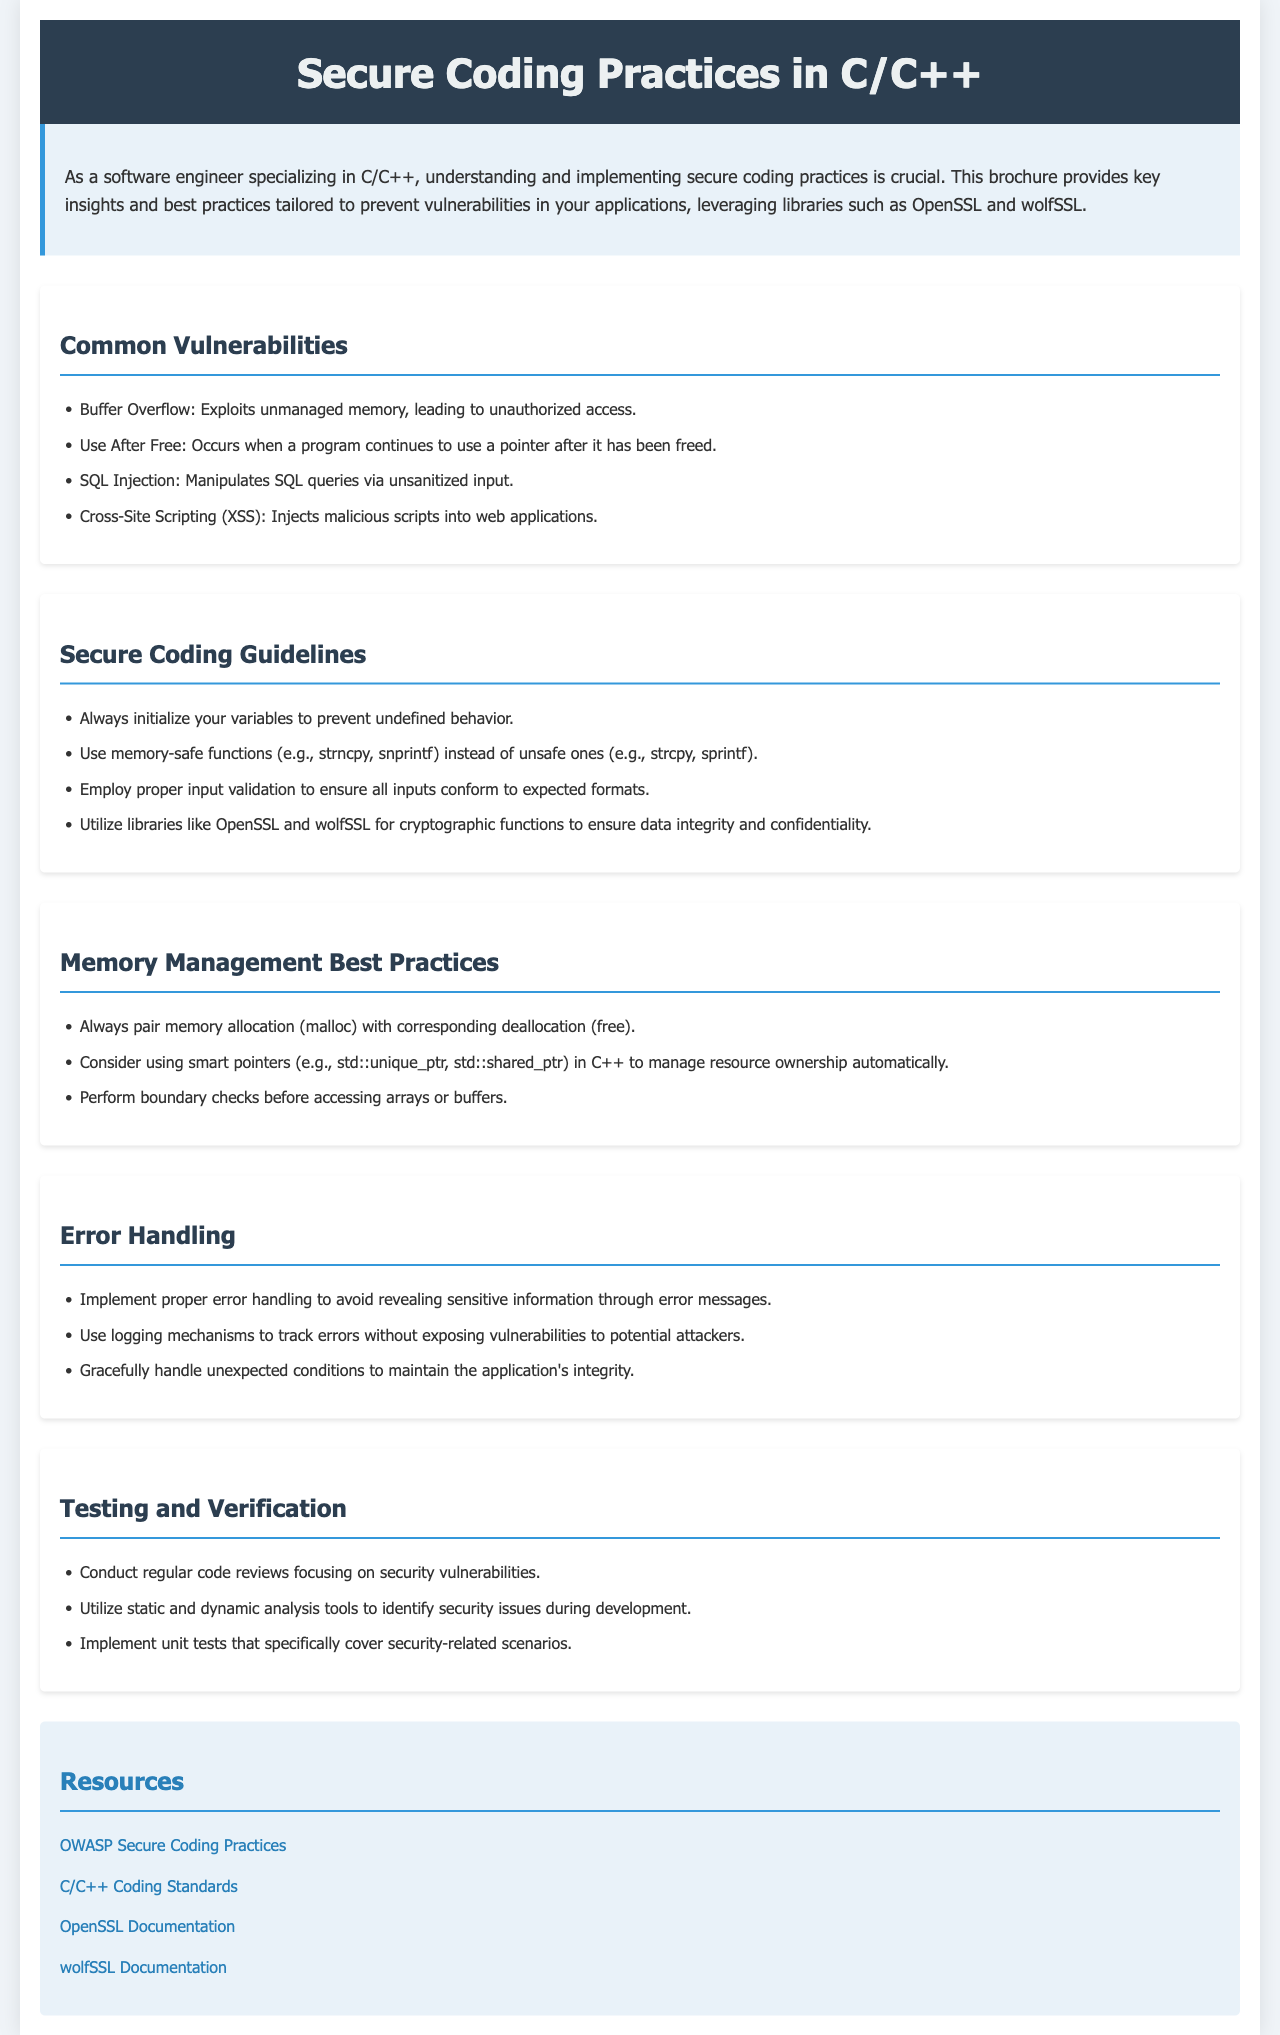What is the title of the brochure? The title is presented at the top of the document, stating the purpose of the content.
Answer: Secure Coding Practices in C/C++ How many sections are in the brochure? The brochure is divided into multiple sections covering different aspects of secure coding practices.
Answer: Five What type of vulnerabilities are listed in the document? The document mentions common vulnerabilities, specifically outlining four examples.
Answer: Buffer Overflow What is recommended to use instead of unsafe functions? The guideline in the document suggests using safer alternatives to avoid memory issues.
Answer: memory-safe functions Which library is mentioned for cryptographic functions? The document encourages the use of a specific library for ensuring cryptographic security.
Answer: OpenSSL What should be paired with memory allocation? The best practice highlighted in the document emphasizes the need for proper deallocation after memory allocation.
Answer: corresponding deallocation What is a suggested way to manage resource ownership in C++? The document provides guidance on using specific types of pointers for automatic resource management in C++.
Answer: smart pointers What does the document recommend for error handling? The guidelines express the importance of a particular approach to manage errors effectively without compromising security.
Answer: proper error handling What resource is linked for secure coding practices? The document provides external resources with links for further reading on secure coding practices.
Answer: OWASP Secure Coding Practices 